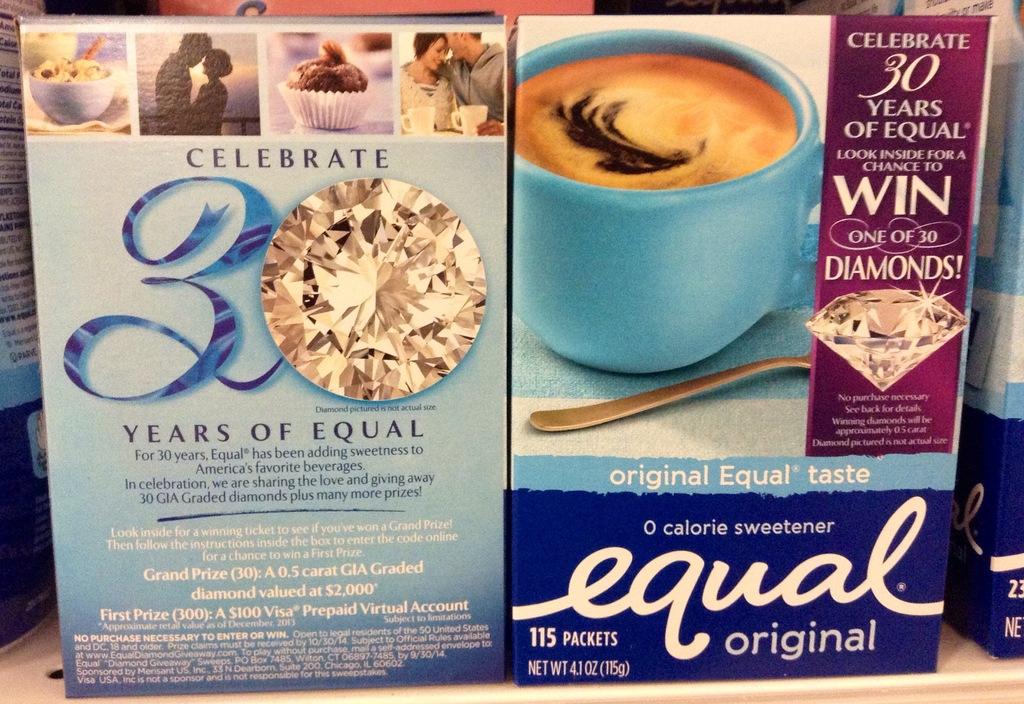Are these original flavored?
Give a very brief answer. Yes. What brand of sweetener is this?
Your answer should be very brief. Equal. 